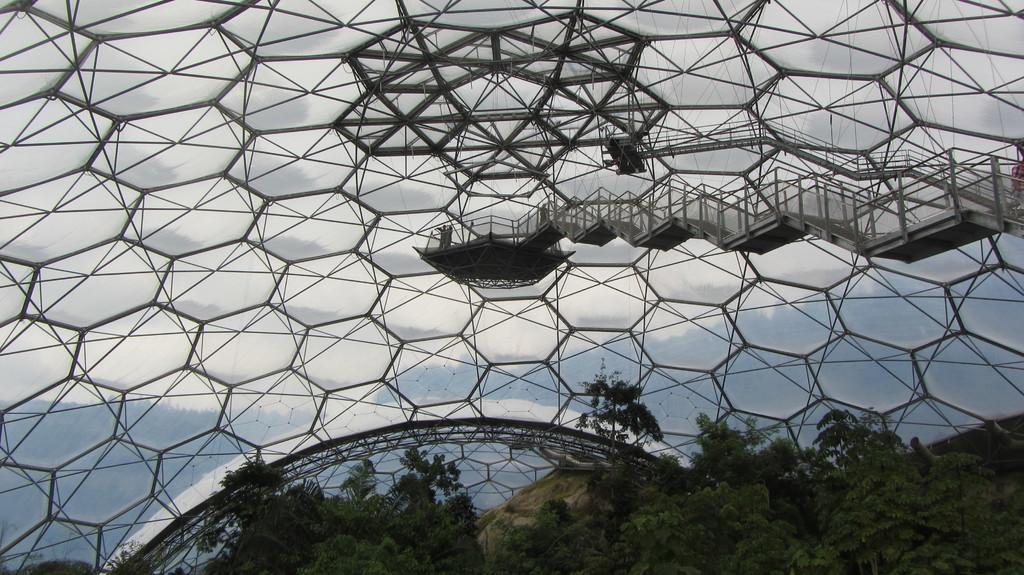Could you give a brief overview of what you see in this image? In the image we can see there are trees and there are designs of hexagon on the glass roof of the building. 